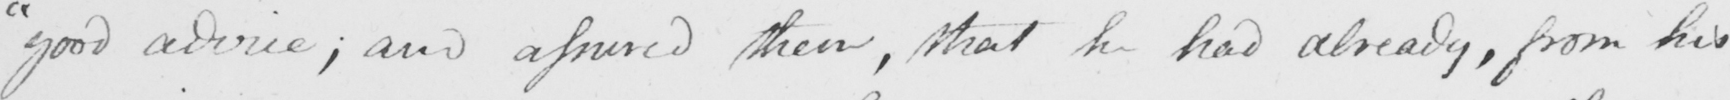Please provide the text content of this handwritten line. " good advice ; and assured them , that he had already , from his 